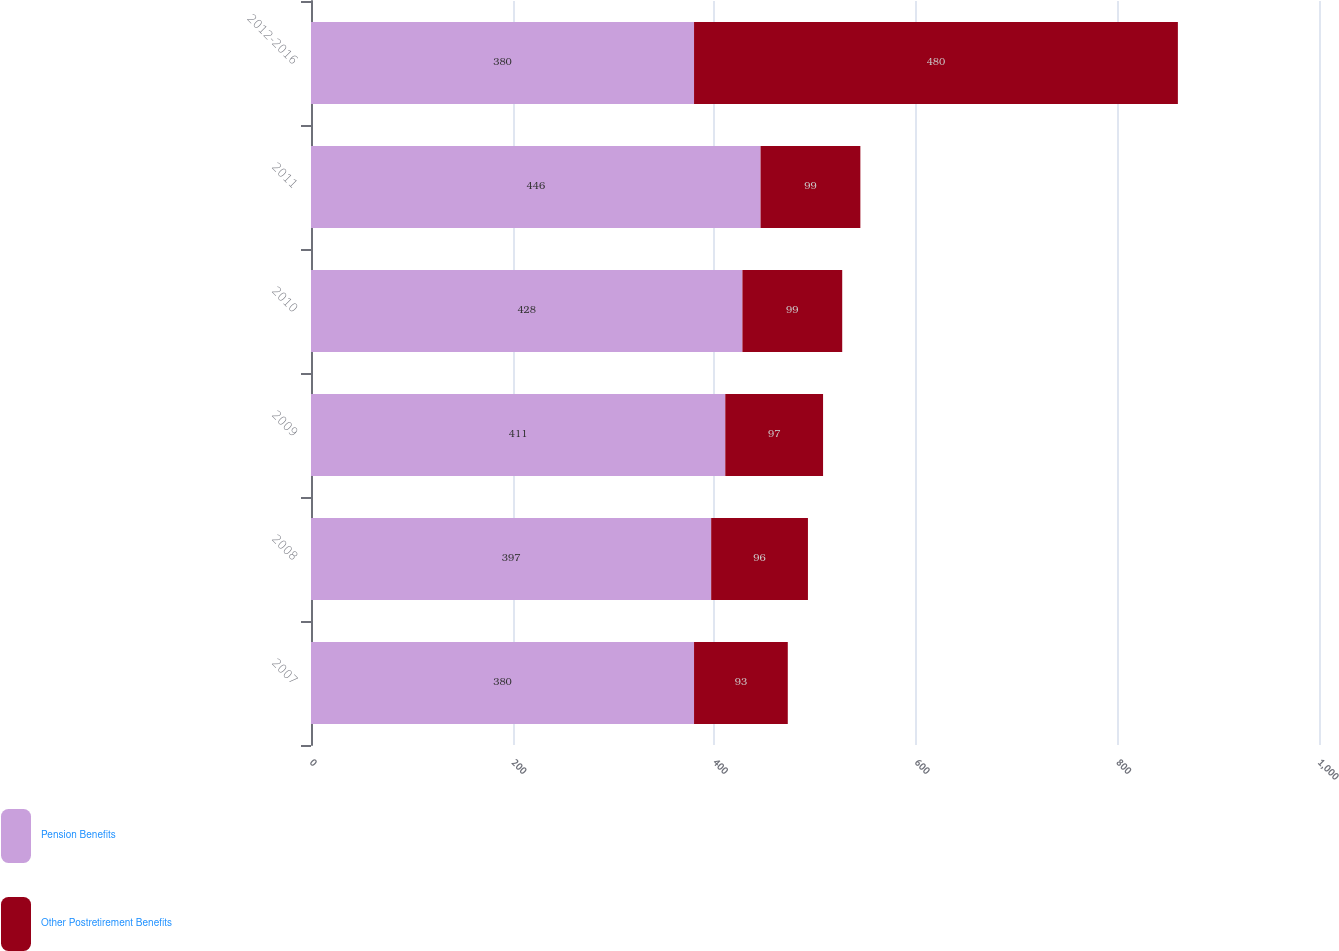Convert chart. <chart><loc_0><loc_0><loc_500><loc_500><stacked_bar_chart><ecel><fcel>2007<fcel>2008<fcel>2009<fcel>2010<fcel>2011<fcel>2012-2016<nl><fcel>Pension Benefits<fcel>380<fcel>397<fcel>411<fcel>428<fcel>446<fcel>380<nl><fcel>Other Postretirement Benefits<fcel>93<fcel>96<fcel>97<fcel>99<fcel>99<fcel>480<nl></chart> 